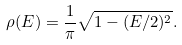Convert formula to latex. <formula><loc_0><loc_0><loc_500><loc_500>\rho ( E ) = \frac { 1 } { \pi } \sqrt { 1 - ( E / 2 ) ^ { 2 } } .</formula> 